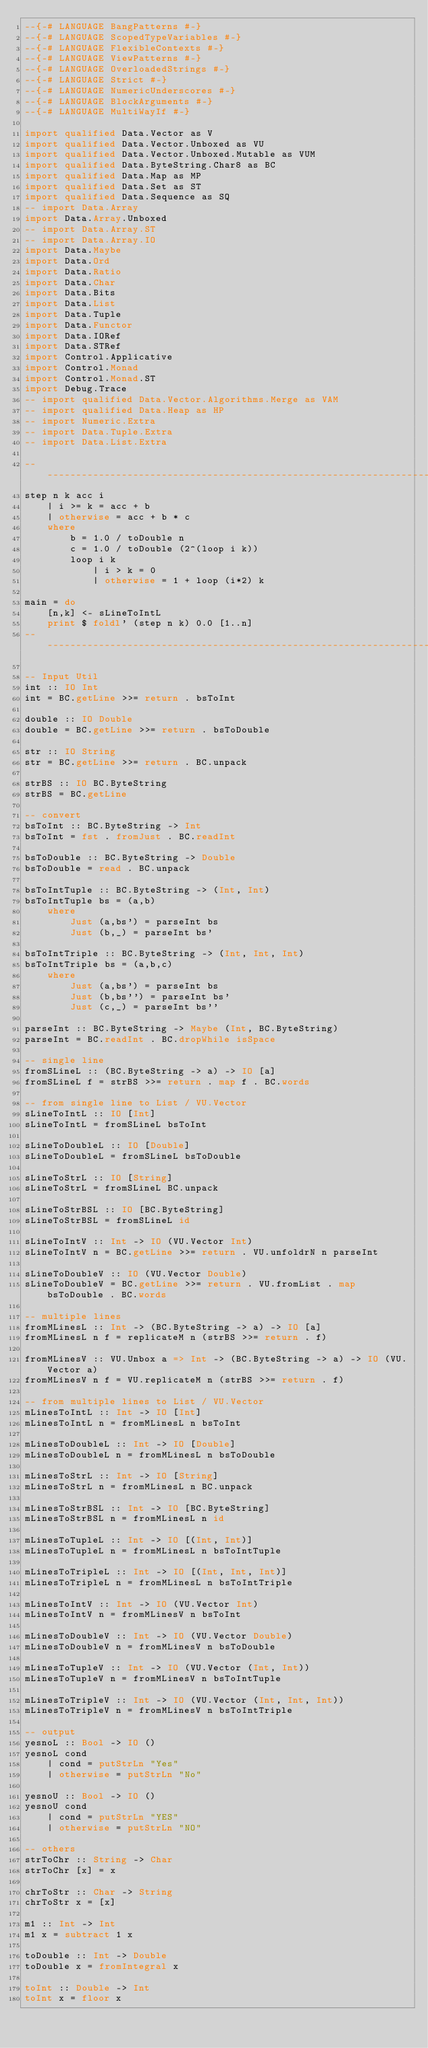Convert code to text. <code><loc_0><loc_0><loc_500><loc_500><_Haskell_>--{-# LANGUAGE BangPatterns #-}
--{-# LANGUAGE ScopedTypeVariables #-}
--{-# LANGUAGE FlexibleContexts #-}
--{-# LANGUAGE ViewPatterns #-}
--{-# LANGUAGE OverloadedStrings #-}
--{-# LANGUAGE Strict #-}
--{-# LANGUAGE NumericUnderscores #-}
--{-# LANGUAGE BlockArguments #-}
--{-# LANGUAGE MultiWayIf #-}

import qualified Data.Vector as V
import qualified Data.Vector.Unboxed as VU
import qualified Data.Vector.Unboxed.Mutable as VUM
import qualified Data.ByteString.Char8 as BC
import qualified Data.Map as MP
import qualified Data.Set as ST
import qualified Data.Sequence as SQ
-- import Data.Array
import Data.Array.Unboxed
-- import Data.Array.ST
-- import Data.Array.IO
import Data.Maybe
import Data.Ord
import Data.Ratio
import Data.Char
import Data.Bits
import Data.List
import Data.Tuple
import Data.Functor
import Data.IORef
import Data.STRef
import Control.Applicative
import Control.Monad
import Control.Monad.ST
import Debug.Trace
-- import qualified Data.Vector.Algorithms.Merge as VAM
-- import qualified Data.Heap as HP
-- import Numeric.Extra
-- import Data.Tuple.Extra
-- import Data.List.Extra

--------------------------------------------------------------------------
step n k acc i
    | i >= k = acc + b
    | otherwise = acc + b * c
    where
        b = 1.0 / toDouble n
        c = 1.0 / toDouble (2^(loop i k))
        loop i k
            | i > k = 0
            | otherwise = 1 + loop (i*2) k

main = do
    [n,k] <- sLineToIntL
    print $ foldl' (step n k) 0.0 [1..n]
--------------------------------------------------------------------------

-- Input Util
int :: IO Int
int = BC.getLine >>= return . bsToInt

double :: IO Double
double = BC.getLine >>= return . bsToDouble

str :: IO String
str = BC.getLine >>= return . BC.unpack

strBS :: IO BC.ByteString
strBS = BC.getLine

-- convert
bsToInt :: BC.ByteString -> Int
bsToInt = fst . fromJust . BC.readInt

bsToDouble :: BC.ByteString -> Double
bsToDouble = read . BC.unpack

bsToIntTuple :: BC.ByteString -> (Int, Int)
bsToIntTuple bs = (a,b)
    where
        Just (a,bs') = parseInt bs
        Just (b,_) = parseInt bs'

bsToIntTriple :: BC.ByteString -> (Int, Int, Int)
bsToIntTriple bs = (a,b,c)
    where
        Just (a,bs') = parseInt bs
        Just (b,bs'') = parseInt bs'
        Just (c,_) = parseInt bs''

parseInt :: BC.ByteString -> Maybe (Int, BC.ByteString)
parseInt = BC.readInt . BC.dropWhile isSpace

-- single line
fromSLineL :: (BC.ByteString -> a) -> IO [a]
fromSLineL f = strBS >>= return . map f . BC.words

-- from single line to List / VU.Vector 
sLineToIntL :: IO [Int]
sLineToIntL = fromSLineL bsToInt

sLineToDoubleL :: IO [Double]
sLineToDoubleL = fromSLineL bsToDouble

sLineToStrL :: IO [String]
sLineToStrL = fromSLineL BC.unpack

sLineToStrBSL :: IO [BC.ByteString]
sLineToStrBSL = fromSLineL id 

sLineToIntV :: Int -> IO (VU.Vector Int)
sLineToIntV n = BC.getLine >>= return . VU.unfoldrN n parseInt

sLineToDoubleV :: IO (VU.Vector Double)
sLineToDoubleV = BC.getLine >>= return . VU.fromList . map bsToDouble . BC.words

-- multiple lines
fromMLinesL :: Int -> (BC.ByteString -> a) -> IO [a]
fromMLinesL n f = replicateM n (strBS >>= return . f)

fromMLinesV :: VU.Unbox a => Int -> (BC.ByteString -> a) -> IO (VU.Vector a)
fromMLinesV n f = VU.replicateM n (strBS >>= return . f)

-- from multiple lines to List / VU.Vector
mLinesToIntL :: Int -> IO [Int]
mLinesToIntL n = fromMLinesL n bsToInt

mLinesToDoubleL :: Int -> IO [Double]
mLinesToDoubleL n = fromMLinesL n bsToDouble

mLinesToStrL :: Int -> IO [String]
mLinesToStrL n = fromMLinesL n BC.unpack

mLinesToStrBSL :: Int -> IO [BC.ByteString]
mLinesToStrBSL n = fromMLinesL n id

mLinesToTupleL :: Int -> IO [(Int, Int)]
mLinesToTupleL n = fromMLinesL n bsToIntTuple

mLinesToTripleL :: Int -> IO [(Int, Int, Int)]
mLinesToTripleL n = fromMLinesL n bsToIntTriple

mLinesToIntV :: Int -> IO (VU.Vector Int)
mLinesToIntV n = fromMLinesV n bsToInt

mLinesToDoubleV :: Int -> IO (VU.Vector Double)
mLinesToDoubleV n = fromMLinesV n bsToDouble

mLinesToTupleV :: Int -> IO (VU.Vector (Int, Int))
mLinesToTupleV n = fromMLinesV n bsToIntTuple
    
mLinesToTripleV :: Int -> IO (VU.Vector (Int, Int, Int))
mLinesToTripleV n = fromMLinesV n bsToIntTriple

-- output
yesnoL :: Bool -> IO ()
yesnoL cond
    | cond = putStrLn "Yes"
    | otherwise = putStrLn "No"

yesnoU :: Bool -> IO ()
yesnoU cond
    | cond = putStrLn "YES"
    | otherwise = putStrLn "NO"

-- others
strToChr :: String -> Char
strToChr [x] = x

chrToStr :: Char -> String
chrToStr x = [x]

m1 :: Int -> Int
m1 x = subtract 1 x

toDouble :: Int -> Double
toDouble x = fromIntegral x

toInt :: Double -> Int
toInt x = floor x
</code> 